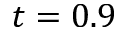Convert formula to latex. <formula><loc_0><loc_0><loc_500><loc_500>t = 0 . 9</formula> 